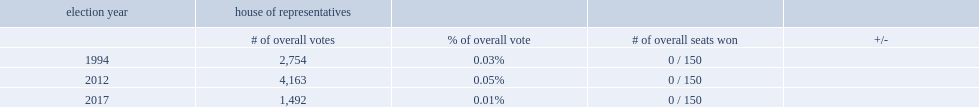How many votes did the libertarian party receive in 2017? 1492.0. 